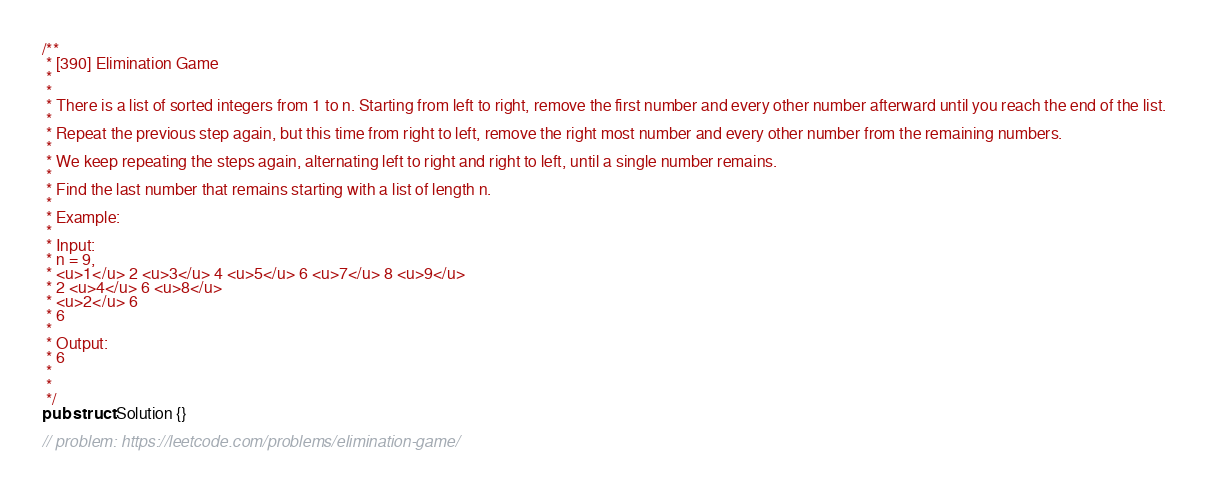<code> <loc_0><loc_0><loc_500><loc_500><_Rust_>/**
 * [390] Elimination Game
 *
 *
 * There is a list of sorted integers from 1 to n. Starting from left to right, remove the first number and every other number afterward until you reach the end of the list.
 *
 * Repeat the previous step again, but this time from right to left, remove the right most number and every other number from the remaining numbers.
 *
 * We keep repeating the steps again, alternating left to right and right to left, until a single number remains.
 *
 * Find the last number that remains starting with a list of length n.
 *
 * Example:
 *
 * Input:
 * n = 9,
 * <u>1</u> 2 <u>3</u> 4 <u>5</u> 6 <u>7</u> 8 <u>9</u>
 * 2 <u>4</u> 6 <u>8</u>
 * <u>2</u> 6
 * 6
 *
 * Output:
 * 6
 *
 *
 */
pub struct Solution {}

// problem: https://leetcode.com/problems/elimination-game/</code> 